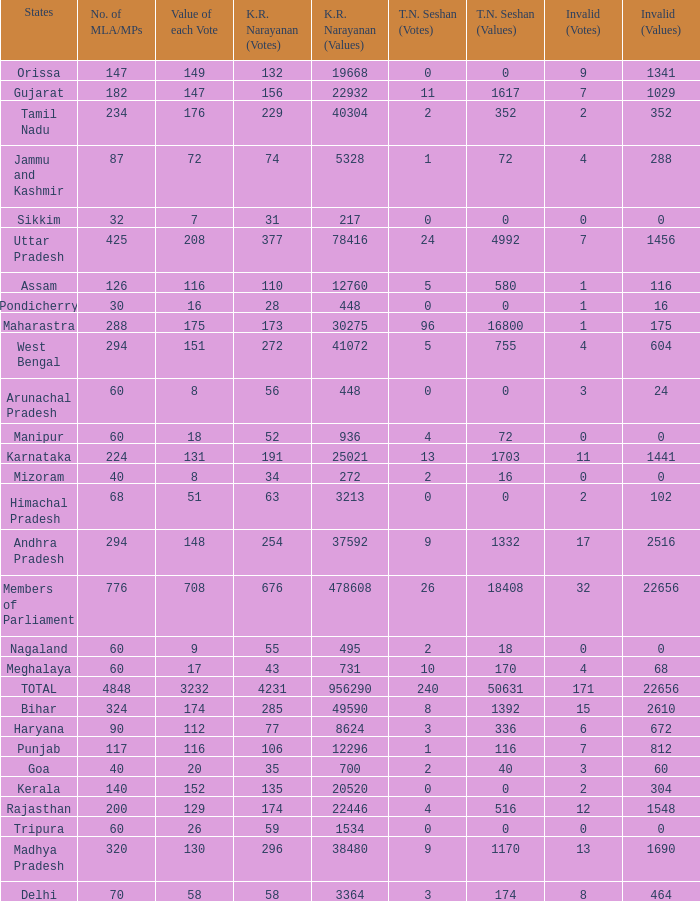Name the kr narayanan votes for values being 936 for kr 52.0. 